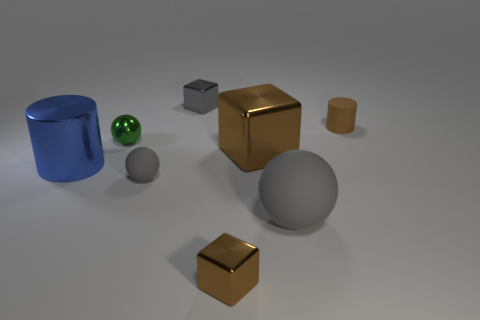There is another sphere that is the same color as the small rubber ball; what size is it?
Provide a succinct answer. Large. Are there any large gray objects that have the same material as the brown cylinder?
Provide a succinct answer. Yes. What is the color of the small cylinder?
Provide a succinct answer. Brown. There is a cylinder that is on the left side of the gray matte object to the right of the tiny shiny thing behind the small cylinder; what is its size?
Make the answer very short. Large. What number of other things are there of the same shape as the blue metallic thing?
Provide a short and direct response. 1. The tiny shiny thing that is behind the metal cylinder and to the right of the green shiny object is what color?
Provide a short and direct response. Gray. There is a small block behind the tiny green shiny sphere; is its color the same as the big ball?
Keep it short and to the point. Yes. What number of balls are brown matte objects or gray matte objects?
Give a very brief answer. 2. What shape is the rubber thing behind the small green thing?
Provide a short and direct response. Cylinder. What is the color of the small rubber object to the right of the gray ball behind the big matte ball that is right of the tiny brown block?
Provide a short and direct response. Brown. 